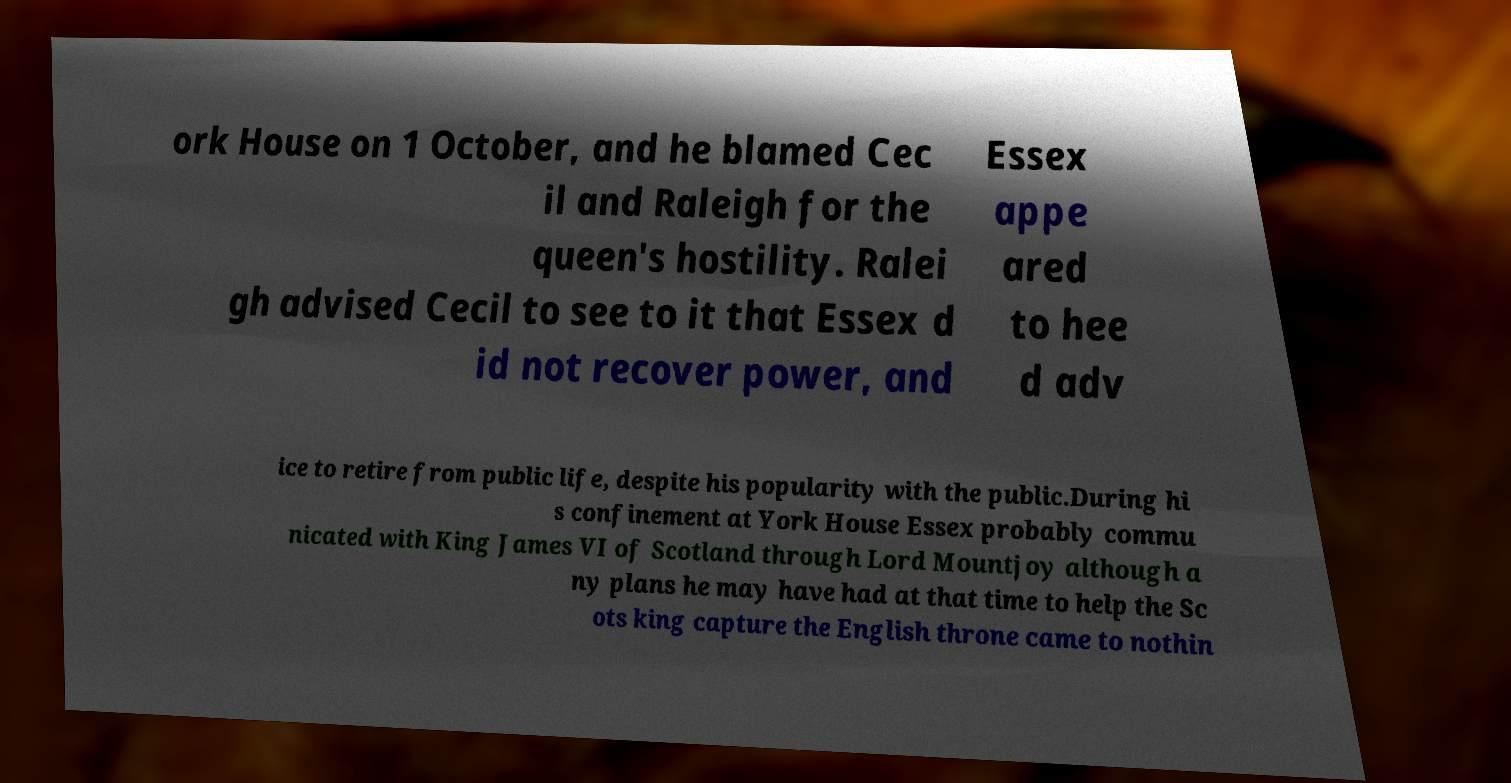Could you extract and type out the text from this image? ork House on 1 October, and he blamed Cec il and Raleigh for the queen's hostility. Ralei gh advised Cecil to see to it that Essex d id not recover power, and Essex appe ared to hee d adv ice to retire from public life, despite his popularity with the public.During hi s confinement at York House Essex probably commu nicated with King James VI of Scotland through Lord Mountjoy although a ny plans he may have had at that time to help the Sc ots king capture the English throne came to nothin 